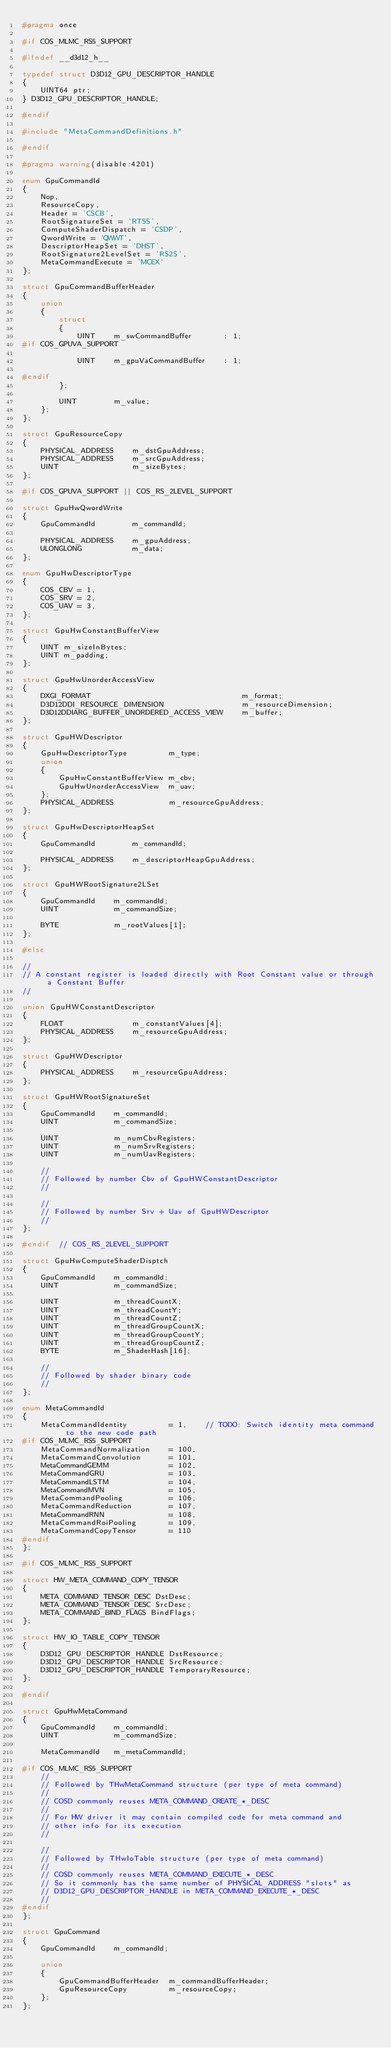<code> <loc_0><loc_0><loc_500><loc_500><_C_>#pragma once

#if COS_MLMC_RS5_SUPPORT

#ifndef __d3d12_h__

typedef struct D3D12_GPU_DESCRIPTOR_HANDLE
{
    UINT64 ptr;
} D3D12_GPU_DESCRIPTOR_HANDLE;

#endif

#include "MetaCommandDefinitions.h"

#endif

#pragma warning(disable:4201)

enum GpuCommandId
{
    Nop,
    ResourceCopy,
    Header = 'CSCB',
    RootSignatureSet = 'RTSS',
    ComputeShaderDispatch = 'CSDP',
    QwordWrite = 'QWWT',
    DescriptorHeapSet = 'DHST',
    RootSignature2LevelSet = 'RS2S',
    MetaCommandExecute = 'MCEX'
};

struct GpuCommandBufferHeader
{
    union
    {
        struct
        {
            UINT    m_swCommandBuffer       : 1;
#if COS_GPUVA_SUPPORT

            UINT    m_gpuVaCommandBuffer    : 1;

#endif
        };

        UINT        m_value;
    };
};

struct GpuResourceCopy
{
    PHYSICAL_ADDRESS    m_dstGpuAddress;
    PHYSICAL_ADDRESS    m_srcGpuAddress;
    UINT                m_sizeBytes;
};

#if COS_GPUVA_SUPPORT || COS_RS_2LEVEL_SUPPORT

struct GpuHwQwordWrite
{
    GpuCommandId        m_commandId;

    PHYSICAL_ADDRESS    m_gpuAddress;
    ULONGLONG           m_data;
};

enum GpuHwDescriptorType
{
    COS_CBV = 1,
    COS_SRV = 2,
    COS_UAV = 3,
};

struct GpuHwConstantBufferView
{
    UINT m_sizeInBytes;
    UINT m_padding;
};

struct GpuHwUnorderAccessView
{
    DXGI_FORMAT                                 m_format;
    D3D12DDI_RESOURCE_DIMENSION                 m_resourceDimension;
    D3D12DDIARG_BUFFER_UNORDERED_ACCESS_VIEW    m_buffer;
};

struct GpuHWDescriptor
{
    GpuHwDescriptorType         m_type;
    union
    {
        GpuHwConstantBufferView m_cbv;
        GpuHwUnorderAccessView  m_uav;
    };
    PHYSICAL_ADDRESS            m_resourceGpuAddress;
};

struct GpuHwDescriptorHeapSet
{
    GpuCommandId        m_commandId;

    PHYSICAL_ADDRESS    m_descriptorHeapGpuAddress;
};

struct GpuHWRootSignature2LSet
{
    GpuCommandId    m_commandId;
    UINT            m_commandSize;

    BYTE            m_rootValues[1];
};

#else

//
// A constant register is loaded directly with Root Constant value or through a Constant Buffer
//

union GpuHWConstantDescriptor
{
    FLOAT               m_constantValues[4];
    PHYSICAL_ADDRESS    m_resourceGpuAddress;
};

struct GpuHWDescriptor
{
    PHYSICAL_ADDRESS    m_resourceGpuAddress;
};

struct GpuHWRootSignatureSet
{
    GpuCommandId    m_commandId;
    UINT            m_commandSize;

    UINT            m_numCbvRegisters;
    UINT            m_numSrvRegisters;
    UINT            m_numUavRegisters;

    //
    // Followed by number Cbv of GpuHWConstantDescriptor
    //

    //
    // Followed by number Srv + Uav of GpuHWDescriptor
    //
};

#endif  // COS_RS_2LEVEL_SUPPORT

struct GpuHwComputeShaderDisptch
{
    GpuCommandId    m_commandId;
    UINT            m_commandSize;

    UINT            m_threadCountX;
    UINT            m_threadCountY;
    UINT            m_threadCountZ;
    UINT            m_threadGroupCountX;
    UINT            m_threadGroupCountY;
    UINT            m_threadGroupCountZ;
    BYTE            m_ShaderHash[16];

    //
    // Followed by shader binary code
    //
};

enum MetaCommandId
{
    MetaCommandIdentity         = 1,    // TODO: Switch identity meta command to the new code path
#if COS_MLMC_RS5_SUPPORT
    MetaCommandNormalization    = 100,
    MetaCommandConvolution      = 101,
    MetaCommandGEMM             = 102,
    MetaCommandGRU              = 103,
    MetaCommandLSTM             = 104,
    MetaCommandMVN              = 105,
    MetaCommandPooling          = 106,
    MetaCommandReduction        = 107,
    MetaCommandRNN              = 108,
    MetaCommandRoiPooling       = 109,
    MetaCommandCopyTensor       = 110
#endif
};

#if COS_MLMC_RS5_SUPPORT

struct HW_META_COMMAND_COPY_TENSOR
{
    META_COMMAND_TENSOR_DESC DstDesc;
    META_COMMAND_TENSOR_DESC SrcDesc;
    META_COMMAND_BIND_FLAGS BindFlags;
};

struct HW_IO_TABLE_COPY_TENSOR
{
    D3D12_GPU_DESCRIPTOR_HANDLE DstResource;
    D3D12_GPU_DESCRIPTOR_HANDLE SrcResource;
    D3D12_GPU_DESCRIPTOR_HANDLE TemporaryResource;
};

#endif

struct GpuHwMetaCommand
{
    GpuCommandId    m_commandId;
    UINT            m_commandSize;

    MetaCommandId   m_metaCommandId;

#if COS_MLMC_RS5_SUPPORT
    //
    // Followed by THwMetaCommand structure (per type of meta command)
    //
    // COSD commonly reuses META_COMMAND_CREATE_*_DESC
    //
    // For HW driver it may contain compiled code for meta command and
    // other info for its execution
    //

    //
    // Followed by THwIoTable structure (per type of meta command)
    //
    // COSD commonly reuses META_COMMAND_EXECUTE_*_DESC
    // So it commonly has the same number of PHYSICAL_ADDRESS "slots" as
    // D3D12_GPU_DESCRIPTOR_HANDLE in META_COMMAND_EXECUTE_*_DESC
    //
#endif
};

struct GpuCommand
{
    GpuCommandId    m_commandId;

    union
    {
        GpuCommandBufferHeader  m_commandBufferHeader;
        GpuResourceCopy         m_resourceCopy;
    };
};
</code> 